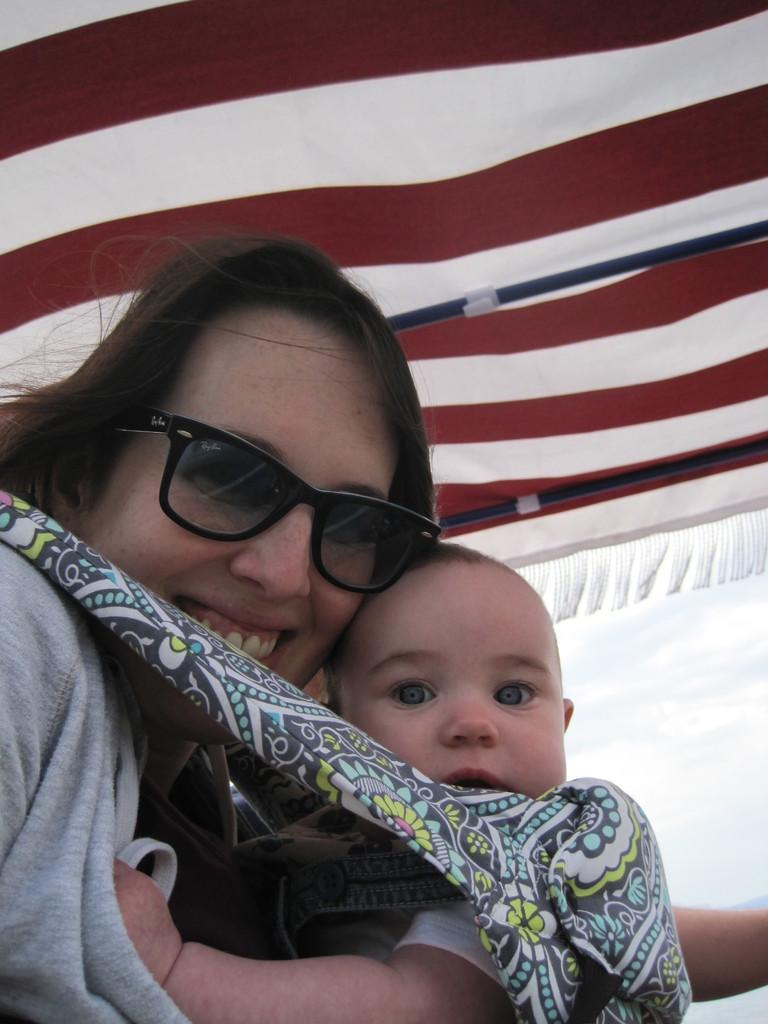Who is the main subject in the image? There is a woman in the image. What is the woman doing in the image? The woman is holding a baby. What can be seen in the background of the image? There is a white and red tent in the background of the image. What type of history can be seen in the image? There is no specific historical event or reference in the image; it features a woman holding a baby with a tent in the background. 